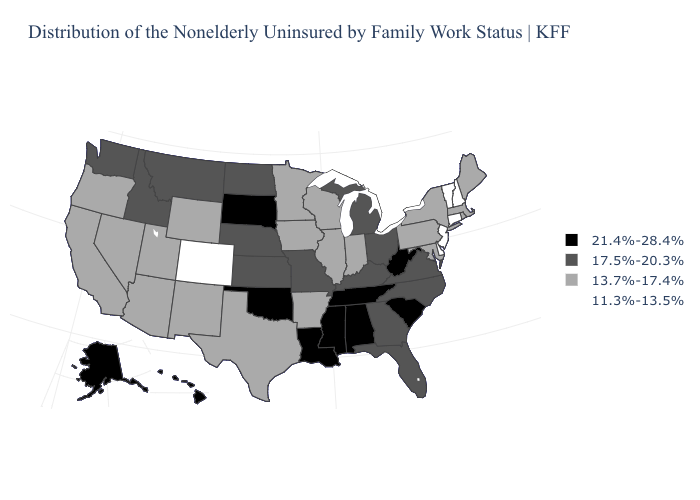What is the value of Maine?
Give a very brief answer. 13.7%-17.4%. Name the states that have a value in the range 21.4%-28.4%?
Answer briefly. Alabama, Alaska, Hawaii, Louisiana, Mississippi, Oklahoma, South Carolina, South Dakota, Tennessee, West Virginia. Name the states that have a value in the range 21.4%-28.4%?
Answer briefly. Alabama, Alaska, Hawaii, Louisiana, Mississippi, Oklahoma, South Carolina, South Dakota, Tennessee, West Virginia. Does Massachusetts have the same value as Utah?
Answer briefly. Yes. What is the value of Michigan?
Answer briefly. 17.5%-20.3%. Name the states that have a value in the range 11.3%-13.5%?
Quick response, please. Colorado, Connecticut, Delaware, New Hampshire, New Jersey, Vermont. Does West Virginia have a lower value than Vermont?
Write a very short answer. No. Does New York have the lowest value in the USA?
Keep it brief. No. What is the value of Mississippi?
Write a very short answer. 21.4%-28.4%. What is the value of Pennsylvania?
Concise answer only. 13.7%-17.4%. Does Maine have the same value as Alaska?
Quick response, please. No. What is the value of Nevada?
Be succinct. 13.7%-17.4%. What is the value of Florida?
Be succinct. 17.5%-20.3%. What is the highest value in the MidWest ?
Answer briefly. 21.4%-28.4%. Name the states that have a value in the range 17.5%-20.3%?
Short answer required. Florida, Georgia, Idaho, Kansas, Kentucky, Michigan, Missouri, Montana, Nebraska, North Carolina, North Dakota, Ohio, Virginia, Washington. 